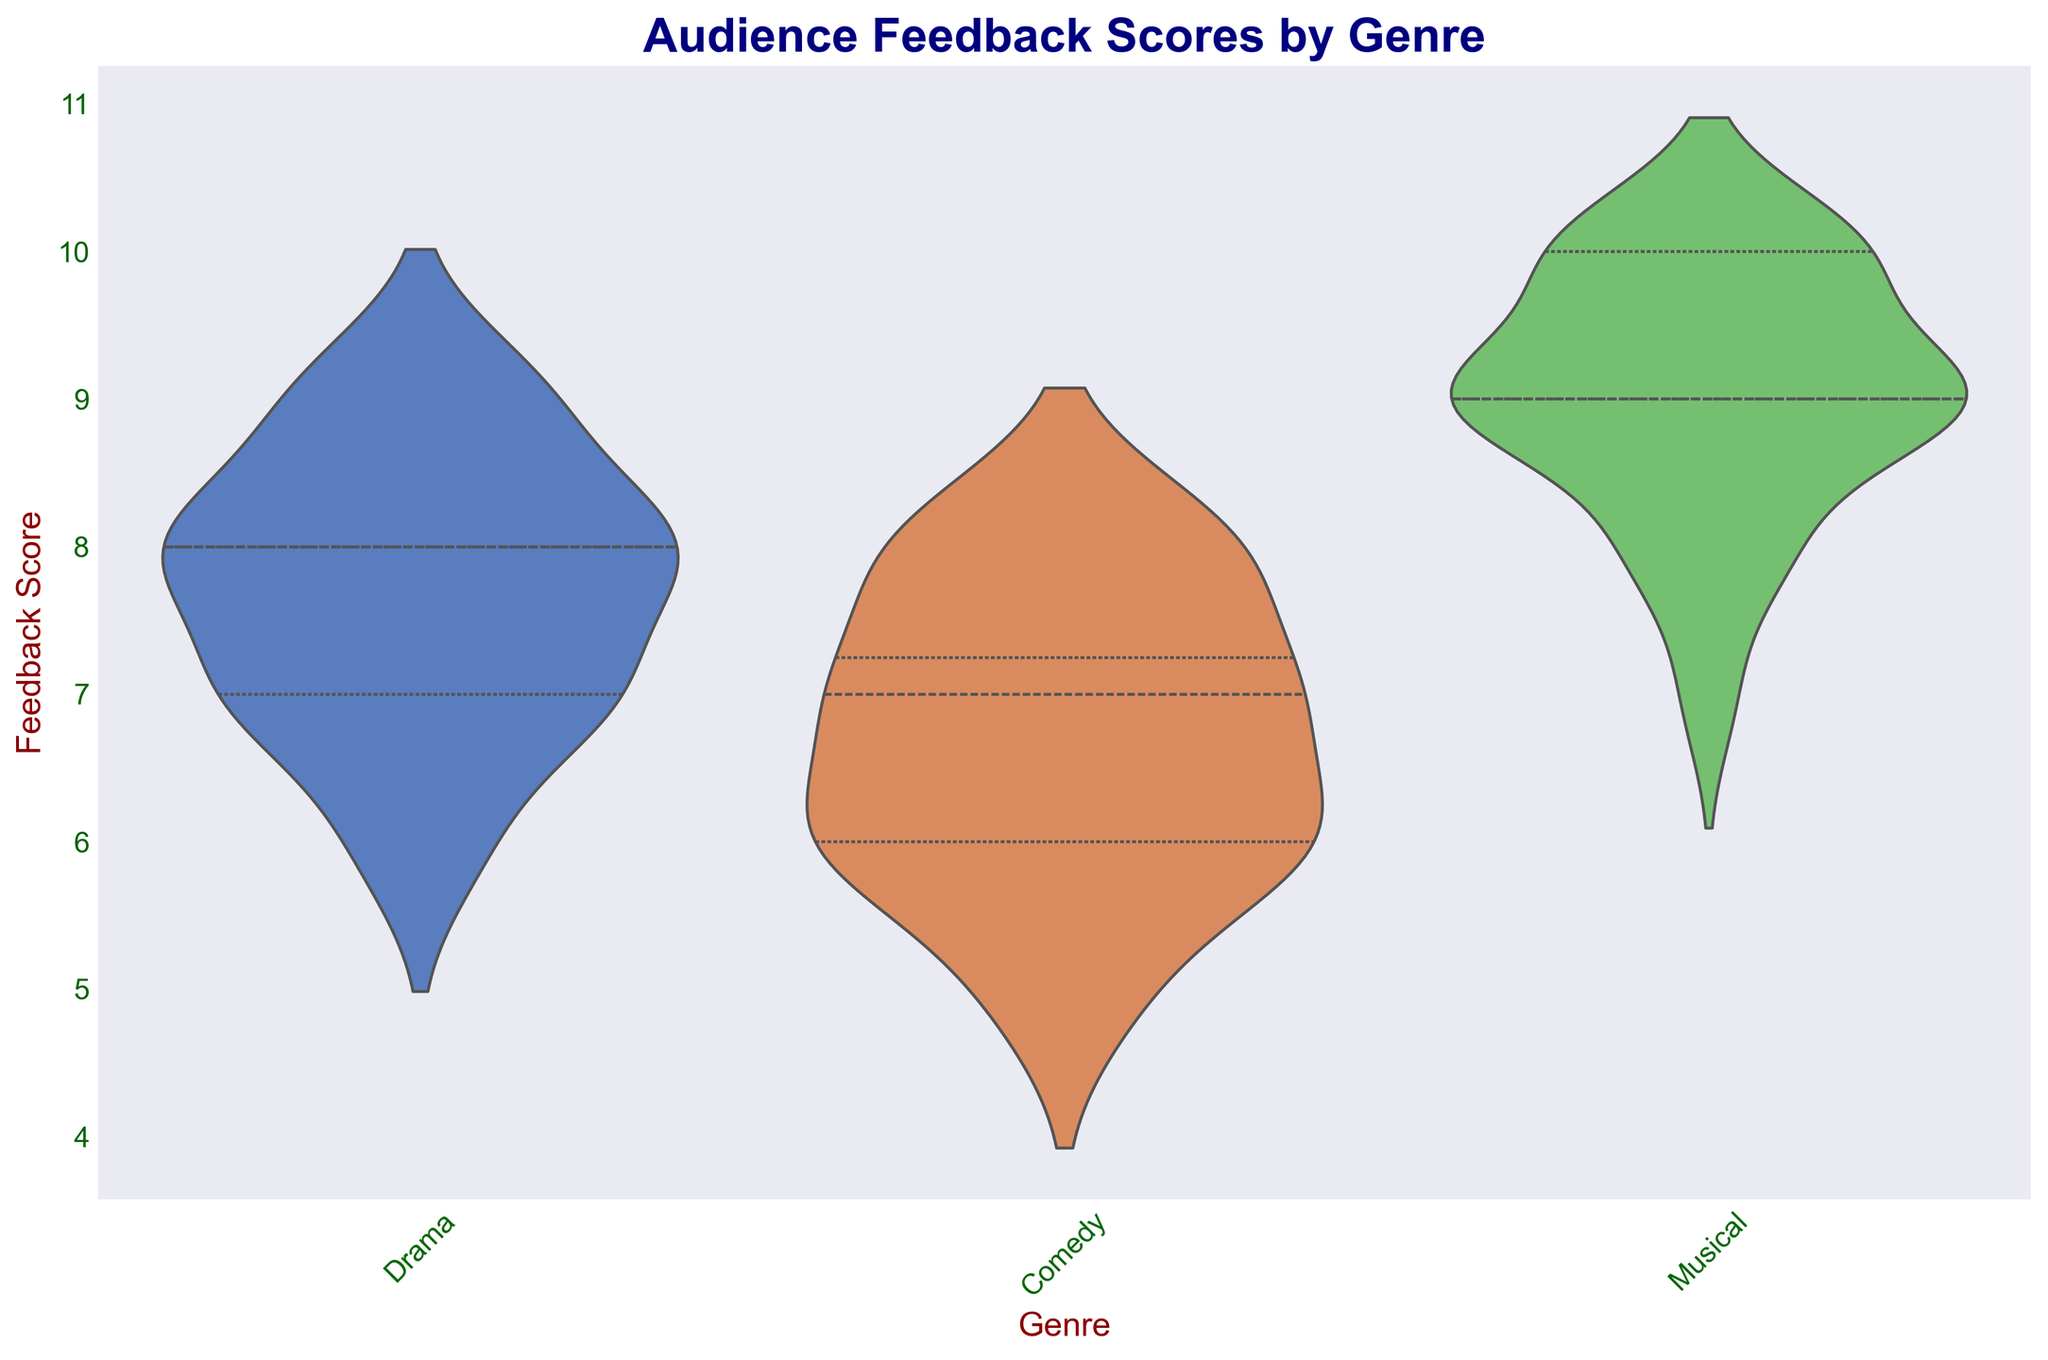Which genre has the highest median feedback score? According to the violin plot, the median feedback scores are indicated by the white dot within each violin. Observing these dots, the Musical genre has the highest median feedback score.
Answer: Musical Which genre shows the widest range of feedback scores? In the violin plot, the range of feedback scores extends from the top to the bottom of each violin. By comparing the lengths of the violins, the Drama genre shows the widest range of feedback scores.
Answer: Drama Which genre has the most concentrated feedback scores? Concentration of scores in a violin plot is indicated by the width of the plot at different score levels. The narrower the plot, the more concentrated the scores. The Comedy genre has the most concentrated feedback scores, as indicated by the narrow shape of its violin.
Answer: Comedy What is the approximate range of feedback scores for Musicals? Observing the ends of the violin for the Musical genre, the feedback scores range from about 7 to 10.
Answer: 7 to 10 Is the median feedback score of Comedies higher or lower than that of Dramas? By comparing the median lines (white dots) of the Comedy and Drama violins, the median feedback score for Dramas is higher than that of Comedies.
Answer: Higher What is the range of feedback scores for Dramas? Looking at the Drama violin, the scores range from approximately 6 to 9.
Answer: 6 to 9 How does the distribution of feedback scores for Comedies differ from that of Musicals? The Comedy violin plot is narrower and more concentrated around its median compared to the wider and more spread-out violin for Musicals. This indicates that Comedies have less variability in feedback scores, whereas Musicals have a broader range.
Answer: Comedy is more concentrated; Musical is more spread out What is the shape of the feedback score distribution for the Drama genre? The Drama violin plot shows a relatively wider middle and narrow ends, indicating a bimodal distribution concentrated around the lower and higher ends of the middle scores (around 7 and 9).
Answer: Bimodal Does any genre show symmetry in the distribution of feedback scores? The Musical genre's violin plot appears to be symmetric around its median, as the upper and lower portions are mirror images.
Answer: Musical Which genre's feedback scores span the smallest number of points? Comparing the range of all genres, the Comedy genre spans the smallest number of points, from around 5 to 8.
Answer: Comedy 